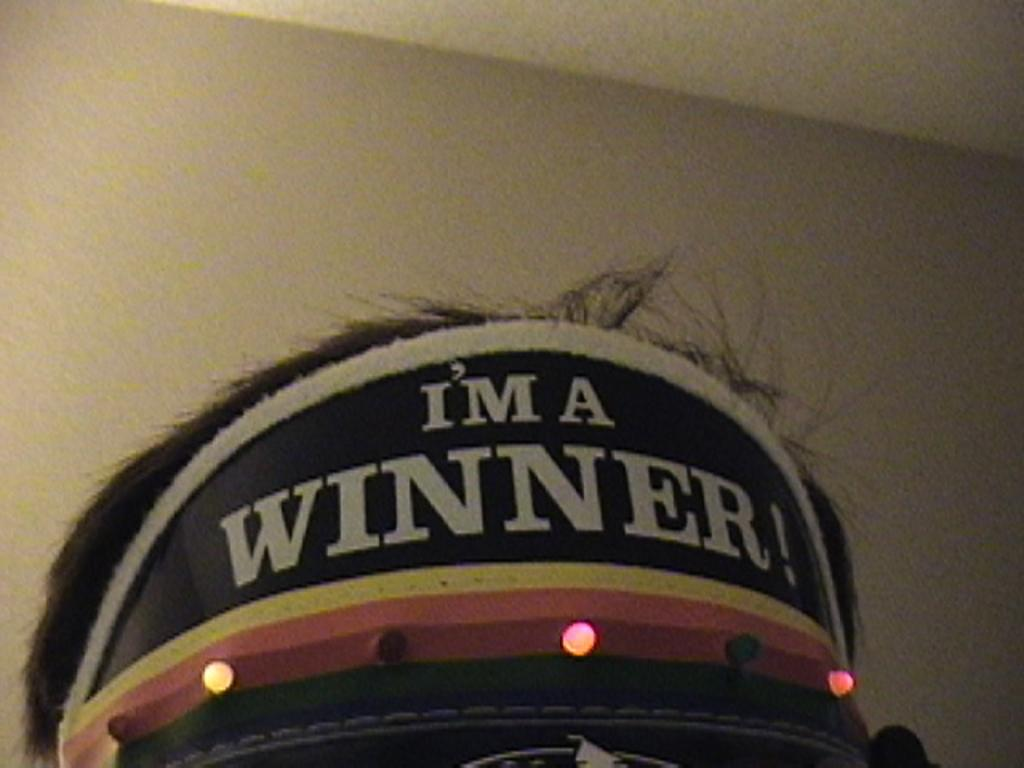What is the main subject of the image? The main subject of the image is a cap. What is written on the cap? There is a text written on the cap in the image. Can you see any oatmeal on the cap in the image? There is no oatmeal present on the cap in the image. Are there any ants crawling on the cap in the image? There are no ants visible on the cap in the image. 